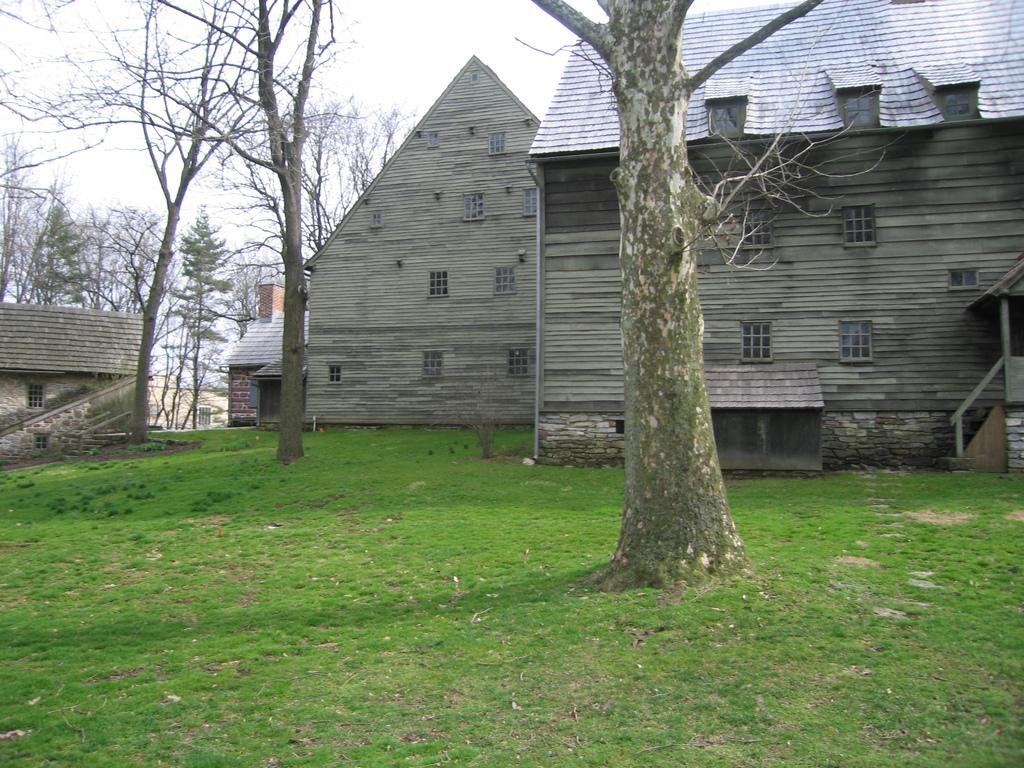What type of structures can be seen in the image? There are houses in the image. What architectural feature is present in the image? There is a staircase in the image. What type of vegetation is visible in the image? There are trees and dried trees in the image. What is on the ground in the image? There are objects and grass on the ground in the image. What is visible at the top of the image? The sky is visible at the top of the image. What type of potato is being played in the background of the image? There is no potato present in the image, nor is there any indication of a song or range. 